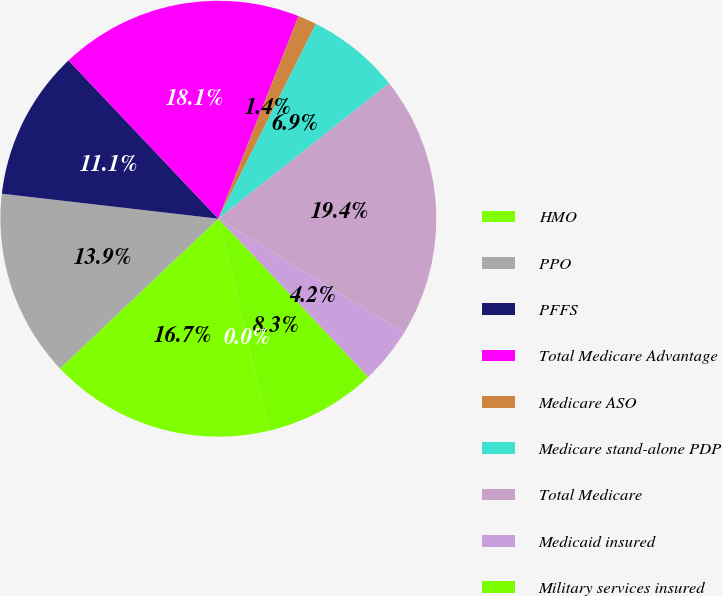Convert chart. <chart><loc_0><loc_0><loc_500><loc_500><pie_chart><fcel>HMO<fcel>PPO<fcel>PFFS<fcel>Total Medicare Advantage<fcel>Medicare ASO<fcel>Medicare stand-alone PDP<fcel>Total Medicare<fcel>Medicaid insured<fcel>Military services insured<fcel>Military services ASO<nl><fcel>16.67%<fcel>13.89%<fcel>11.11%<fcel>18.06%<fcel>1.39%<fcel>6.94%<fcel>19.44%<fcel>4.17%<fcel>8.33%<fcel>0.0%<nl></chart> 